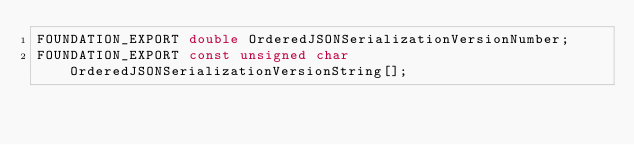Convert code to text. <code><loc_0><loc_0><loc_500><loc_500><_C_>FOUNDATION_EXPORT double OrderedJSONSerializationVersionNumber;
FOUNDATION_EXPORT const unsigned char OrderedJSONSerializationVersionString[];

</code> 